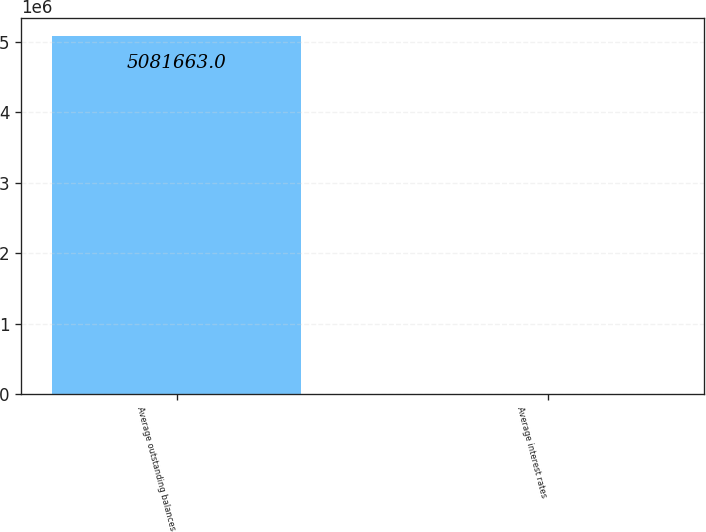Convert chart. <chart><loc_0><loc_0><loc_500><loc_500><bar_chart><fcel>Average outstanding balances<fcel>Average interest rates<nl><fcel>5.08166e+06<fcel>4.11<nl></chart> 